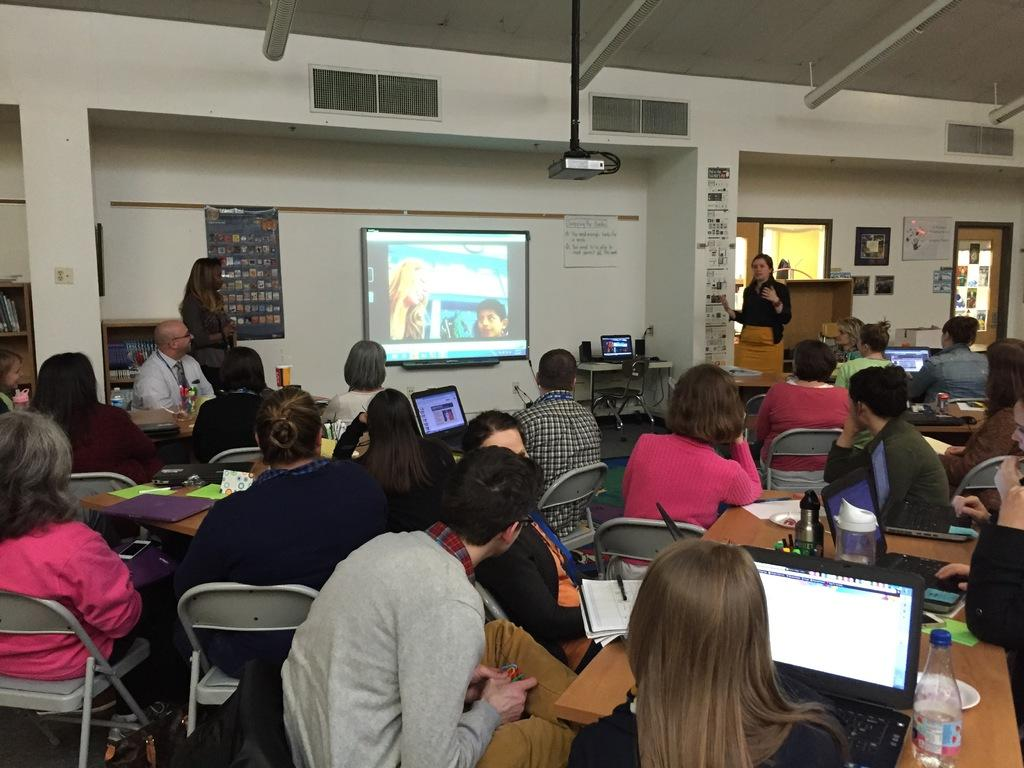What is the color of the wall in the image? The wall in the image is white. What can be seen hanging on the wall? There is a banner in the image. What is the main object in the room? There is a screen in the image. What device is used to project images onto the screen? There is a projector in the image. What are the people in the image doing? The people are sitting on chairs in the image. What objects are on the tables in the image? There are laptops and books on the tables in the image. What direction is the hospital facing in the image? There is no hospital present in the image. What is the chance of winning a prize in the image? There is no mention of a prize or chance in the image. 